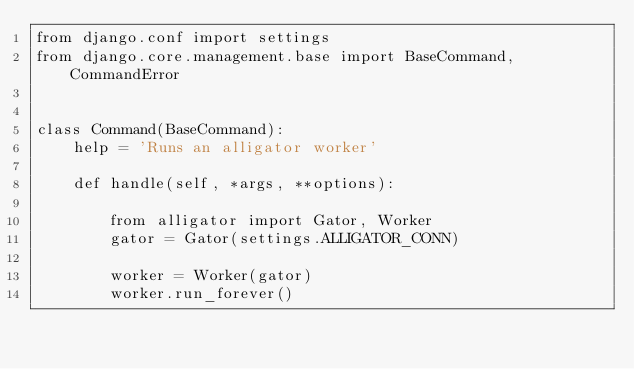<code> <loc_0><loc_0><loc_500><loc_500><_Python_>from django.conf import settings
from django.core.management.base import BaseCommand, CommandError


class Command(BaseCommand):
    help = 'Runs an alligator worker'

    def handle(self, *args, **options):

        from alligator import Gator, Worker
        gator = Gator(settings.ALLIGATOR_CONN)

        worker = Worker(gator)
        worker.run_forever()
</code> 